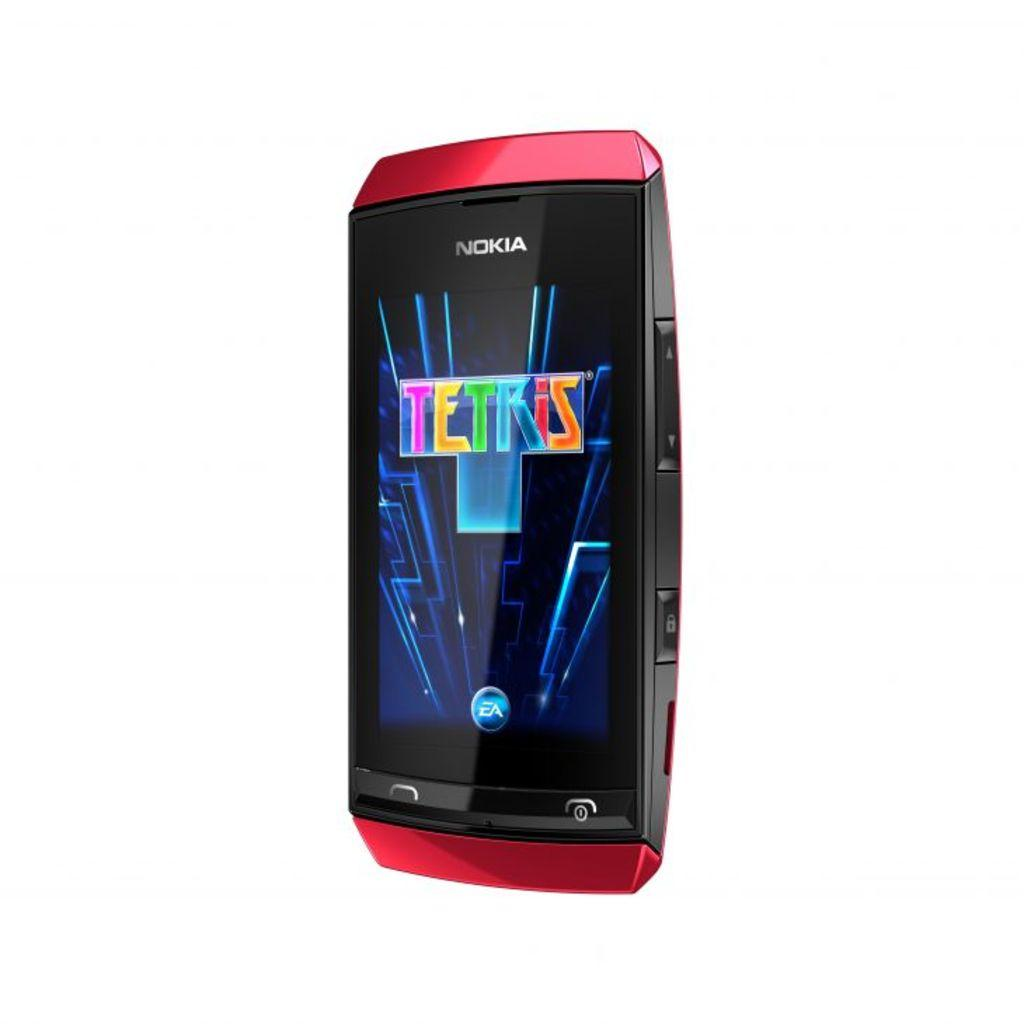<image>
Provide a brief description of the given image. A red Nokia phone with a Tetris home screen. 